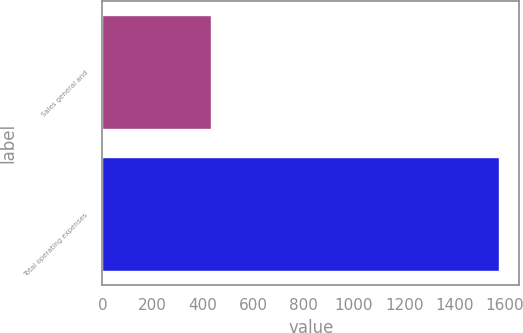Convert chart to OTSL. <chart><loc_0><loc_0><loc_500><loc_500><bar_chart><fcel>Sales general and<fcel>Total operating expenses<nl><fcel>430.8<fcel>1578.1<nl></chart> 